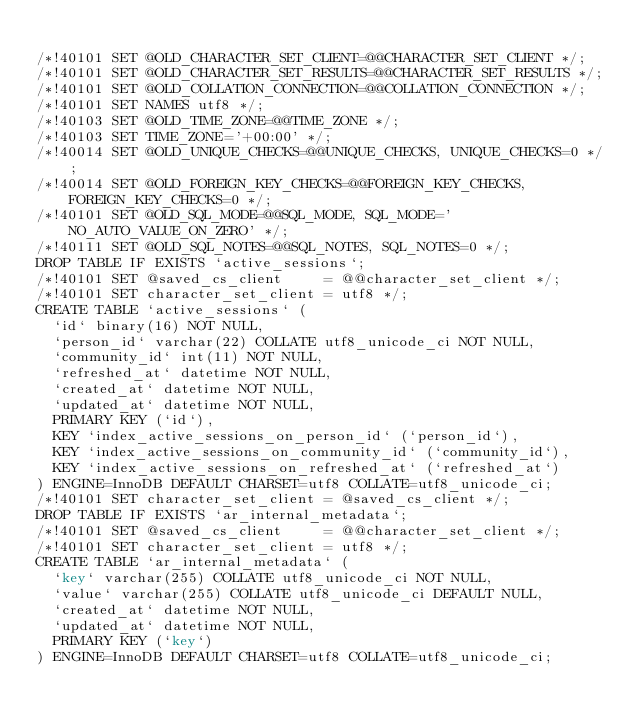Convert code to text. <code><loc_0><loc_0><loc_500><loc_500><_SQL_>
/*!40101 SET @OLD_CHARACTER_SET_CLIENT=@@CHARACTER_SET_CLIENT */;
/*!40101 SET @OLD_CHARACTER_SET_RESULTS=@@CHARACTER_SET_RESULTS */;
/*!40101 SET @OLD_COLLATION_CONNECTION=@@COLLATION_CONNECTION */;
/*!40101 SET NAMES utf8 */;
/*!40103 SET @OLD_TIME_ZONE=@@TIME_ZONE */;
/*!40103 SET TIME_ZONE='+00:00' */;
/*!40014 SET @OLD_UNIQUE_CHECKS=@@UNIQUE_CHECKS, UNIQUE_CHECKS=0 */;
/*!40014 SET @OLD_FOREIGN_KEY_CHECKS=@@FOREIGN_KEY_CHECKS, FOREIGN_KEY_CHECKS=0 */;
/*!40101 SET @OLD_SQL_MODE=@@SQL_MODE, SQL_MODE='NO_AUTO_VALUE_ON_ZERO' */;
/*!40111 SET @OLD_SQL_NOTES=@@SQL_NOTES, SQL_NOTES=0 */;
DROP TABLE IF EXISTS `active_sessions`;
/*!40101 SET @saved_cs_client     = @@character_set_client */;
/*!40101 SET character_set_client = utf8 */;
CREATE TABLE `active_sessions` (
  `id` binary(16) NOT NULL,
  `person_id` varchar(22) COLLATE utf8_unicode_ci NOT NULL,
  `community_id` int(11) NOT NULL,
  `refreshed_at` datetime NOT NULL,
  `created_at` datetime NOT NULL,
  `updated_at` datetime NOT NULL,
  PRIMARY KEY (`id`),
  KEY `index_active_sessions_on_person_id` (`person_id`),
  KEY `index_active_sessions_on_community_id` (`community_id`),
  KEY `index_active_sessions_on_refreshed_at` (`refreshed_at`)
) ENGINE=InnoDB DEFAULT CHARSET=utf8 COLLATE=utf8_unicode_ci;
/*!40101 SET character_set_client = @saved_cs_client */;
DROP TABLE IF EXISTS `ar_internal_metadata`;
/*!40101 SET @saved_cs_client     = @@character_set_client */;
/*!40101 SET character_set_client = utf8 */;
CREATE TABLE `ar_internal_metadata` (
  `key` varchar(255) COLLATE utf8_unicode_ci NOT NULL,
  `value` varchar(255) COLLATE utf8_unicode_ci DEFAULT NULL,
  `created_at` datetime NOT NULL,
  `updated_at` datetime NOT NULL,
  PRIMARY KEY (`key`)
) ENGINE=InnoDB DEFAULT CHARSET=utf8 COLLATE=utf8_unicode_ci;</code> 